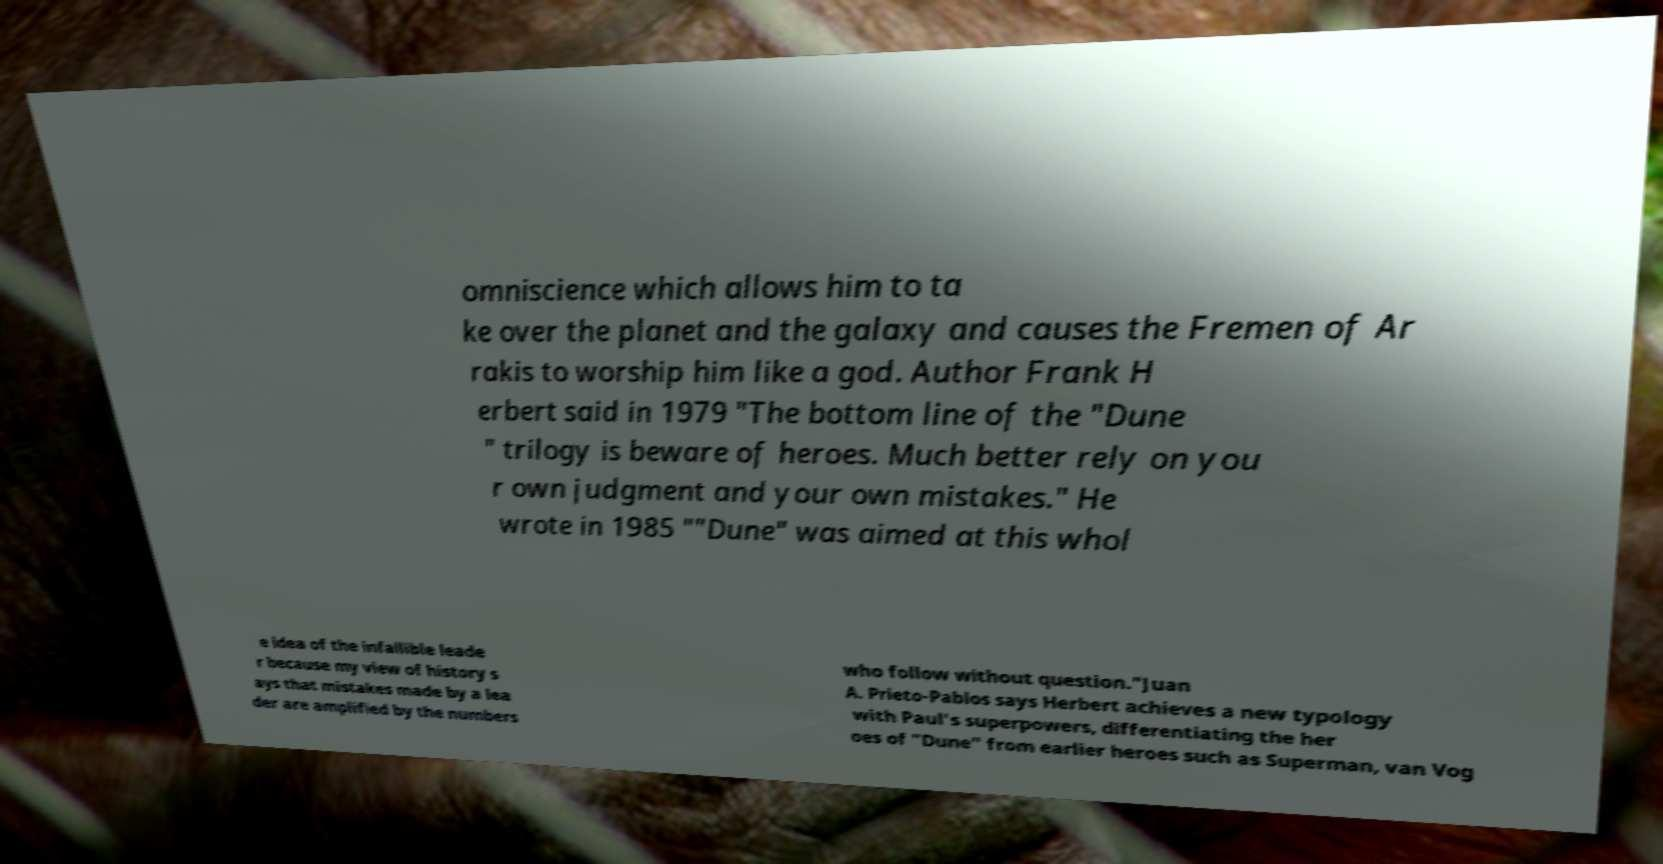Can you accurately transcribe the text from the provided image for me? omniscience which allows him to ta ke over the planet and the galaxy and causes the Fremen of Ar rakis to worship him like a god. Author Frank H erbert said in 1979 "The bottom line of the "Dune " trilogy is beware of heroes. Much better rely on you r own judgment and your own mistakes." He wrote in 1985 ""Dune" was aimed at this whol e idea of the infallible leade r because my view of history s ays that mistakes made by a lea der are amplified by the numbers who follow without question."Juan A. Prieto-Pablos says Herbert achieves a new typology with Paul's superpowers, differentiating the her oes of "Dune" from earlier heroes such as Superman, van Vog 